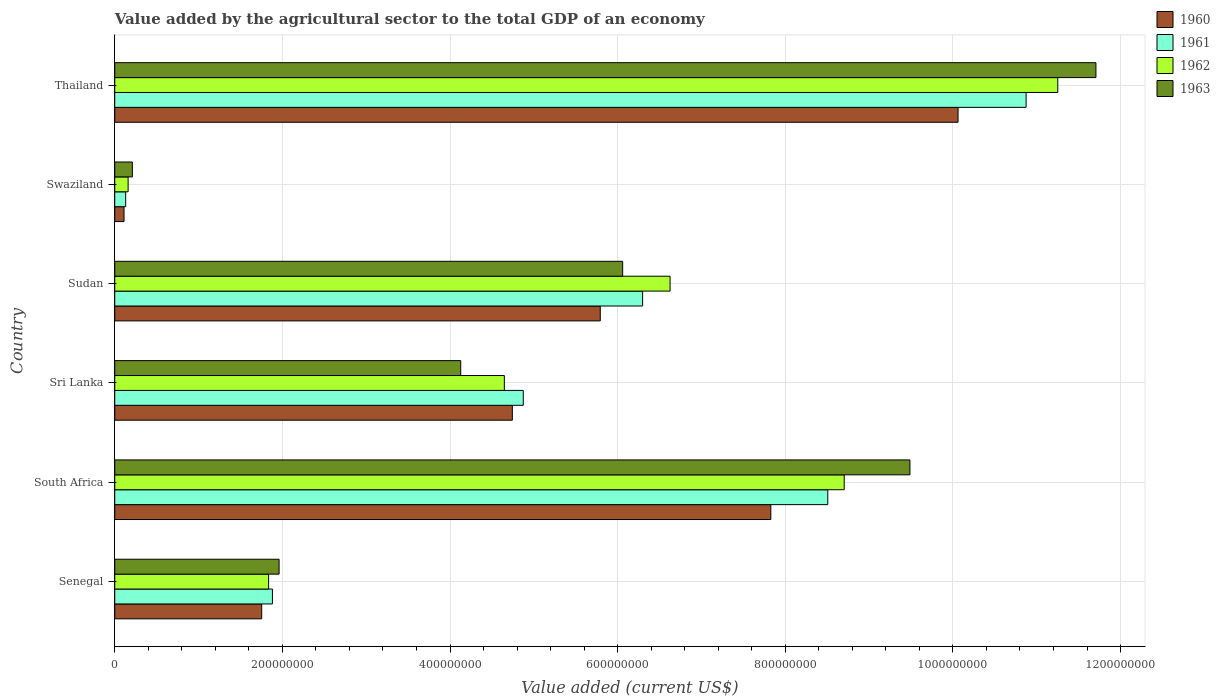How many different coloured bars are there?
Offer a very short reply. 4. Are the number of bars on each tick of the Y-axis equal?
Your answer should be very brief. Yes. How many bars are there on the 4th tick from the top?
Provide a short and direct response. 4. How many bars are there on the 1st tick from the bottom?
Offer a very short reply. 4. What is the label of the 4th group of bars from the top?
Make the answer very short. Sri Lanka. In how many cases, is the number of bars for a given country not equal to the number of legend labels?
Your response must be concise. 0. What is the value added by the agricultural sector to the total GDP in 1963 in Sudan?
Give a very brief answer. 6.06e+08. Across all countries, what is the maximum value added by the agricultural sector to the total GDP in 1961?
Your answer should be very brief. 1.09e+09. Across all countries, what is the minimum value added by the agricultural sector to the total GDP in 1961?
Offer a terse response. 1.30e+07. In which country was the value added by the agricultural sector to the total GDP in 1963 maximum?
Provide a short and direct response. Thailand. In which country was the value added by the agricultural sector to the total GDP in 1962 minimum?
Provide a short and direct response. Swaziland. What is the total value added by the agricultural sector to the total GDP in 1962 in the graph?
Keep it short and to the point. 3.32e+09. What is the difference between the value added by the agricultural sector to the total GDP in 1963 in South Africa and that in Thailand?
Your response must be concise. -2.22e+08. What is the difference between the value added by the agricultural sector to the total GDP in 1962 in Sri Lanka and the value added by the agricultural sector to the total GDP in 1960 in Senegal?
Make the answer very short. 2.89e+08. What is the average value added by the agricultural sector to the total GDP in 1963 per country?
Make the answer very short. 5.59e+08. What is the difference between the value added by the agricultural sector to the total GDP in 1961 and value added by the agricultural sector to the total GDP in 1962 in Thailand?
Make the answer very short. -3.78e+07. In how many countries, is the value added by the agricultural sector to the total GDP in 1962 greater than 960000000 US$?
Offer a terse response. 1. What is the ratio of the value added by the agricultural sector to the total GDP in 1960 in Senegal to that in Thailand?
Provide a succinct answer. 0.17. What is the difference between the highest and the second highest value added by the agricultural sector to the total GDP in 1962?
Offer a very short reply. 2.55e+08. What is the difference between the highest and the lowest value added by the agricultural sector to the total GDP in 1960?
Make the answer very short. 9.95e+08. In how many countries, is the value added by the agricultural sector to the total GDP in 1960 greater than the average value added by the agricultural sector to the total GDP in 1960 taken over all countries?
Offer a very short reply. 3. Is the sum of the value added by the agricultural sector to the total GDP in 1963 in South Africa and Sudan greater than the maximum value added by the agricultural sector to the total GDP in 1961 across all countries?
Keep it short and to the point. Yes. How many bars are there?
Offer a terse response. 24. What is the difference between two consecutive major ticks on the X-axis?
Offer a terse response. 2.00e+08. Are the values on the major ticks of X-axis written in scientific E-notation?
Keep it short and to the point. No. Does the graph contain any zero values?
Make the answer very short. No. Where does the legend appear in the graph?
Give a very brief answer. Top right. How are the legend labels stacked?
Offer a terse response. Vertical. What is the title of the graph?
Provide a short and direct response. Value added by the agricultural sector to the total GDP of an economy. What is the label or title of the X-axis?
Make the answer very short. Value added (current US$). What is the Value added (current US$) in 1960 in Senegal?
Your response must be concise. 1.75e+08. What is the Value added (current US$) in 1961 in Senegal?
Provide a succinct answer. 1.88e+08. What is the Value added (current US$) of 1962 in Senegal?
Ensure brevity in your answer.  1.84e+08. What is the Value added (current US$) of 1963 in Senegal?
Offer a very short reply. 1.96e+08. What is the Value added (current US$) of 1960 in South Africa?
Make the answer very short. 7.83e+08. What is the Value added (current US$) of 1961 in South Africa?
Make the answer very short. 8.51e+08. What is the Value added (current US$) in 1962 in South Africa?
Offer a very short reply. 8.70e+08. What is the Value added (current US$) in 1963 in South Africa?
Keep it short and to the point. 9.49e+08. What is the Value added (current US$) of 1960 in Sri Lanka?
Offer a very short reply. 4.74e+08. What is the Value added (current US$) in 1961 in Sri Lanka?
Make the answer very short. 4.87e+08. What is the Value added (current US$) in 1962 in Sri Lanka?
Make the answer very short. 4.65e+08. What is the Value added (current US$) in 1963 in Sri Lanka?
Provide a succinct answer. 4.13e+08. What is the Value added (current US$) of 1960 in Sudan?
Your answer should be very brief. 5.79e+08. What is the Value added (current US$) of 1961 in Sudan?
Make the answer very short. 6.30e+08. What is the Value added (current US$) of 1962 in Sudan?
Make the answer very short. 6.63e+08. What is the Value added (current US$) in 1963 in Sudan?
Your response must be concise. 6.06e+08. What is the Value added (current US$) of 1960 in Swaziland?
Keep it short and to the point. 1.11e+07. What is the Value added (current US$) in 1961 in Swaziland?
Offer a very short reply. 1.30e+07. What is the Value added (current US$) of 1962 in Swaziland?
Keep it short and to the point. 1.60e+07. What is the Value added (current US$) in 1963 in Swaziland?
Make the answer very short. 2.10e+07. What is the Value added (current US$) of 1960 in Thailand?
Your response must be concise. 1.01e+09. What is the Value added (current US$) in 1961 in Thailand?
Offer a terse response. 1.09e+09. What is the Value added (current US$) of 1962 in Thailand?
Your answer should be very brief. 1.13e+09. What is the Value added (current US$) of 1963 in Thailand?
Your response must be concise. 1.17e+09. Across all countries, what is the maximum Value added (current US$) in 1960?
Ensure brevity in your answer.  1.01e+09. Across all countries, what is the maximum Value added (current US$) of 1961?
Ensure brevity in your answer.  1.09e+09. Across all countries, what is the maximum Value added (current US$) of 1962?
Ensure brevity in your answer.  1.13e+09. Across all countries, what is the maximum Value added (current US$) of 1963?
Keep it short and to the point. 1.17e+09. Across all countries, what is the minimum Value added (current US$) of 1960?
Give a very brief answer. 1.11e+07. Across all countries, what is the minimum Value added (current US$) of 1961?
Your response must be concise. 1.30e+07. Across all countries, what is the minimum Value added (current US$) of 1962?
Your answer should be very brief. 1.60e+07. Across all countries, what is the minimum Value added (current US$) of 1963?
Provide a succinct answer. 2.10e+07. What is the total Value added (current US$) of 1960 in the graph?
Your answer should be very brief. 3.03e+09. What is the total Value added (current US$) of 1961 in the graph?
Offer a very short reply. 3.26e+09. What is the total Value added (current US$) of 1962 in the graph?
Make the answer very short. 3.32e+09. What is the total Value added (current US$) of 1963 in the graph?
Your answer should be very brief. 3.36e+09. What is the difference between the Value added (current US$) of 1960 in Senegal and that in South Africa?
Make the answer very short. -6.07e+08. What is the difference between the Value added (current US$) of 1961 in Senegal and that in South Africa?
Your answer should be compact. -6.63e+08. What is the difference between the Value added (current US$) of 1962 in Senegal and that in South Africa?
Ensure brevity in your answer.  -6.87e+08. What is the difference between the Value added (current US$) in 1963 in Senegal and that in South Africa?
Provide a succinct answer. -7.53e+08. What is the difference between the Value added (current US$) in 1960 in Senegal and that in Sri Lanka?
Give a very brief answer. -2.99e+08. What is the difference between the Value added (current US$) in 1961 in Senegal and that in Sri Lanka?
Provide a succinct answer. -2.99e+08. What is the difference between the Value added (current US$) in 1962 in Senegal and that in Sri Lanka?
Your answer should be very brief. -2.81e+08. What is the difference between the Value added (current US$) in 1963 in Senegal and that in Sri Lanka?
Ensure brevity in your answer.  -2.17e+08. What is the difference between the Value added (current US$) in 1960 in Senegal and that in Sudan?
Keep it short and to the point. -4.04e+08. What is the difference between the Value added (current US$) in 1961 in Senegal and that in Sudan?
Your answer should be very brief. -4.42e+08. What is the difference between the Value added (current US$) in 1962 in Senegal and that in Sudan?
Give a very brief answer. -4.79e+08. What is the difference between the Value added (current US$) of 1963 in Senegal and that in Sudan?
Provide a succinct answer. -4.10e+08. What is the difference between the Value added (current US$) of 1960 in Senegal and that in Swaziland?
Offer a terse response. 1.64e+08. What is the difference between the Value added (current US$) in 1961 in Senegal and that in Swaziland?
Your answer should be very brief. 1.75e+08. What is the difference between the Value added (current US$) in 1962 in Senegal and that in Swaziland?
Offer a terse response. 1.68e+08. What is the difference between the Value added (current US$) in 1963 in Senegal and that in Swaziland?
Give a very brief answer. 1.75e+08. What is the difference between the Value added (current US$) in 1960 in Senegal and that in Thailand?
Offer a terse response. -8.31e+08. What is the difference between the Value added (current US$) of 1961 in Senegal and that in Thailand?
Offer a very short reply. -8.99e+08. What is the difference between the Value added (current US$) in 1962 in Senegal and that in Thailand?
Offer a very short reply. -9.42e+08. What is the difference between the Value added (current US$) of 1963 in Senegal and that in Thailand?
Offer a very short reply. -9.75e+08. What is the difference between the Value added (current US$) in 1960 in South Africa and that in Sri Lanka?
Make the answer very short. 3.08e+08. What is the difference between the Value added (current US$) in 1961 in South Africa and that in Sri Lanka?
Keep it short and to the point. 3.63e+08. What is the difference between the Value added (current US$) of 1962 in South Africa and that in Sri Lanka?
Your answer should be very brief. 4.06e+08. What is the difference between the Value added (current US$) of 1963 in South Africa and that in Sri Lanka?
Offer a terse response. 5.36e+08. What is the difference between the Value added (current US$) in 1960 in South Africa and that in Sudan?
Offer a very short reply. 2.04e+08. What is the difference between the Value added (current US$) in 1961 in South Africa and that in Sudan?
Your answer should be very brief. 2.21e+08. What is the difference between the Value added (current US$) of 1962 in South Africa and that in Sudan?
Offer a very short reply. 2.08e+08. What is the difference between the Value added (current US$) of 1963 in South Africa and that in Sudan?
Your response must be concise. 3.43e+08. What is the difference between the Value added (current US$) of 1960 in South Africa and that in Swaziland?
Offer a very short reply. 7.72e+08. What is the difference between the Value added (current US$) in 1961 in South Africa and that in Swaziland?
Offer a very short reply. 8.38e+08. What is the difference between the Value added (current US$) of 1962 in South Africa and that in Swaziland?
Give a very brief answer. 8.54e+08. What is the difference between the Value added (current US$) of 1963 in South Africa and that in Swaziland?
Make the answer very short. 9.28e+08. What is the difference between the Value added (current US$) of 1960 in South Africa and that in Thailand?
Offer a terse response. -2.23e+08. What is the difference between the Value added (current US$) in 1961 in South Africa and that in Thailand?
Keep it short and to the point. -2.37e+08. What is the difference between the Value added (current US$) of 1962 in South Africa and that in Thailand?
Your response must be concise. -2.55e+08. What is the difference between the Value added (current US$) in 1963 in South Africa and that in Thailand?
Your answer should be very brief. -2.22e+08. What is the difference between the Value added (current US$) of 1960 in Sri Lanka and that in Sudan?
Make the answer very short. -1.05e+08. What is the difference between the Value added (current US$) of 1961 in Sri Lanka and that in Sudan?
Your answer should be compact. -1.42e+08. What is the difference between the Value added (current US$) of 1962 in Sri Lanka and that in Sudan?
Provide a succinct answer. -1.98e+08. What is the difference between the Value added (current US$) in 1963 in Sri Lanka and that in Sudan?
Make the answer very short. -1.93e+08. What is the difference between the Value added (current US$) in 1960 in Sri Lanka and that in Swaziland?
Provide a succinct answer. 4.63e+08. What is the difference between the Value added (current US$) in 1961 in Sri Lanka and that in Swaziland?
Your answer should be very brief. 4.74e+08. What is the difference between the Value added (current US$) in 1962 in Sri Lanka and that in Swaziland?
Provide a short and direct response. 4.49e+08. What is the difference between the Value added (current US$) of 1963 in Sri Lanka and that in Swaziland?
Your answer should be compact. 3.92e+08. What is the difference between the Value added (current US$) of 1960 in Sri Lanka and that in Thailand?
Your answer should be very brief. -5.32e+08. What is the difference between the Value added (current US$) of 1961 in Sri Lanka and that in Thailand?
Your answer should be compact. -6.00e+08. What is the difference between the Value added (current US$) of 1962 in Sri Lanka and that in Thailand?
Keep it short and to the point. -6.60e+08. What is the difference between the Value added (current US$) in 1963 in Sri Lanka and that in Thailand?
Provide a short and direct response. -7.58e+08. What is the difference between the Value added (current US$) of 1960 in Sudan and that in Swaziland?
Keep it short and to the point. 5.68e+08. What is the difference between the Value added (current US$) of 1961 in Sudan and that in Swaziland?
Give a very brief answer. 6.17e+08. What is the difference between the Value added (current US$) in 1962 in Sudan and that in Swaziland?
Provide a short and direct response. 6.47e+08. What is the difference between the Value added (current US$) of 1963 in Sudan and that in Swaziland?
Offer a very short reply. 5.85e+08. What is the difference between the Value added (current US$) in 1960 in Sudan and that in Thailand?
Ensure brevity in your answer.  -4.27e+08. What is the difference between the Value added (current US$) of 1961 in Sudan and that in Thailand?
Your response must be concise. -4.58e+08. What is the difference between the Value added (current US$) of 1962 in Sudan and that in Thailand?
Make the answer very short. -4.63e+08. What is the difference between the Value added (current US$) in 1963 in Sudan and that in Thailand?
Give a very brief answer. -5.65e+08. What is the difference between the Value added (current US$) in 1960 in Swaziland and that in Thailand?
Offer a terse response. -9.95e+08. What is the difference between the Value added (current US$) of 1961 in Swaziland and that in Thailand?
Your response must be concise. -1.07e+09. What is the difference between the Value added (current US$) in 1962 in Swaziland and that in Thailand?
Provide a short and direct response. -1.11e+09. What is the difference between the Value added (current US$) of 1963 in Swaziland and that in Thailand?
Provide a short and direct response. -1.15e+09. What is the difference between the Value added (current US$) of 1960 in Senegal and the Value added (current US$) of 1961 in South Africa?
Offer a terse response. -6.75e+08. What is the difference between the Value added (current US$) of 1960 in Senegal and the Value added (current US$) of 1962 in South Africa?
Your response must be concise. -6.95e+08. What is the difference between the Value added (current US$) in 1960 in Senegal and the Value added (current US$) in 1963 in South Africa?
Your response must be concise. -7.73e+08. What is the difference between the Value added (current US$) of 1961 in Senegal and the Value added (current US$) of 1962 in South Africa?
Your answer should be compact. -6.82e+08. What is the difference between the Value added (current US$) of 1961 in Senegal and the Value added (current US$) of 1963 in South Africa?
Your answer should be very brief. -7.61e+08. What is the difference between the Value added (current US$) in 1962 in Senegal and the Value added (current US$) in 1963 in South Africa?
Keep it short and to the point. -7.65e+08. What is the difference between the Value added (current US$) in 1960 in Senegal and the Value added (current US$) in 1961 in Sri Lanka?
Provide a short and direct response. -3.12e+08. What is the difference between the Value added (current US$) of 1960 in Senegal and the Value added (current US$) of 1962 in Sri Lanka?
Give a very brief answer. -2.89e+08. What is the difference between the Value added (current US$) of 1960 in Senegal and the Value added (current US$) of 1963 in Sri Lanka?
Give a very brief answer. -2.37e+08. What is the difference between the Value added (current US$) of 1961 in Senegal and the Value added (current US$) of 1962 in Sri Lanka?
Provide a short and direct response. -2.77e+08. What is the difference between the Value added (current US$) in 1961 in Senegal and the Value added (current US$) in 1963 in Sri Lanka?
Keep it short and to the point. -2.25e+08. What is the difference between the Value added (current US$) of 1962 in Senegal and the Value added (current US$) of 1963 in Sri Lanka?
Make the answer very short. -2.29e+08. What is the difference between the Value added (current US$) in 1960 in Senegal and the Value added (current US$) in 1961 in Sudan?
Your answer should be very brief. -4.54e+08. What is the difference between the Value added (current US$) of 1960 in Senegal and the Value added (current US$) of 1962 in Sudan?
Ensure brevity in your answer.  -4.87e+08. What is the difference between the Value added (current US$) of 1960 in Senegal and the Value added (current US$) of 1963 in Sudan?
Ensure brevity in your answer.  -4.31e+08. What is the difference between the Value added (current US$) in 1961 in Senegal and the Value added (current US$) in 1962 in Sudan?
Your answer should be very brief. -4.74e+08. What is the difference between the Value added (current US$) in 1961 in Senegal and the Value added (current US$) in 1963 in Sudan?
Keep it short and to the point. -4.18e+08. What is the difference between the Value added (current US$) in 1962 in Senegal and the Value added (current US$) in 1963 in Sudan?
Your answer should be compact. -4.22e+08. What is the difference between the Value added (current US$) in 1960 in Senegal and the Value added (current US$) in 1961 in Swaziland?
Offer a terse response. 1.62e+08. What is the difference between the Value added (current US$) of 1960 in Senegal and the Value added (current US$) of 1962 in Swaziland?
Your answer should be compact. 1.59e+08. What is the difference between the Value added (current US$) of 1960 in Senegal and the Value added (current US$) of 1963 in Swaziland?
Ensure brevity in your answer.  1.54e+08. What is the difference between the Value added (current US$) of 1961 in Senegal and the Value added (current US$) of 1962 in Swaziland?
Your response must be concise. 1.72e+08. What is the difference between the Value added (current US$) of 1961 in Senegal and the Value added (current US$) of 1963 in Swaziland?
Offer a terse response. 1.67e+08. What is the difference between the Value added (current US$) of 1962 in Senegal and the Value added (current US$) of 1963 in Swaziland?
Make the answer very short. 1.63e+08. What is the difference between the Value added (current US$) of 1960 in Senegal and the Value added (current US$) of 1961 in Thailand?
Provide a succinct answer. -9.12e+08. What is the difference between the Value added (current US$) in 1960 in Senegal and the Value added (current US$) in 1962 in Thailand?
Provide a succinct answer. -9.50e+08. What is the difference between the Value added (current US$) of 1960 in Senegal and the Value added (current US$) of 1963 in Thailand?
Your answer should be compact. -9.95e+08. What is the difference between the Value added (current US$) of 1961 in Senegal and the Value added (current US$) of 1962 in Thailand?
Your response must be concise. -9.37e+08. What is the difference between the Value added (current US$) in 1961 in Senegal and the Value added (current US$) in 1963 in Thailand?
Your response must be concise. -9.83e+08. What is the difference between the Value added (current US$) of 1962 in Senegal and the Value added (current US$) of 1963 in Thailand?
Provide a short and direct response. -9.87e+08. What is the difference between the Value added (current US$) in 1960 in South Africa and the Value added (current US$) in 1961 in Sri Lanka?
Your answer should be very brief. 2.95e+08. What is the difference between the Value added (current US$) of 1960 in South Africa and the Value added (current US$) of 1962 in Sri Lanka?
Ensure brevity in your answer.  3.18e+08. What is the difference between the Value added (current US$) of 1960 in South Africa and the Value added (current US$) of 1963 in Sri Lanka?
Give a very brief answer. 3.70e+08. What is the difference between the Value added (current US$) of 1961 in South Africa and the Value added (current US$) of 1962 in Sri Lanka?
Provide a short and direct response. 3.86e+08. What is the difference between the Value added (current US$) of 1961 in South Africa and the Value added (current US$) of 1963 in Sri Lanka?
Your answer should be compact. 4.38e+08. What is the difference between the Value added (current US$) of 1962 in South Africa and the Value added (current US$) of 1963 in Sri Lanka?
Your response must be concise. 4.58e+08. What is the difference between the Value added (current US$) in 1960 in South Africa and the Value added (current US$) in 1961 in Sudan?
Offer a terse response. 1.53e+08. What is the difference between the Value added (current US$) in 1960 in South Africa and the Value added (current US$) in 1962 in Sudan?
Provide a succinct answer. 1.20e+08. What is the difference between the Value added (current US$) of 1960 in South Africa and the Value added (current US$) of 1963 in Sudan?
Provide a succinct answer. 1.77e+08. What is the difference between the Value added (current US$) of 1961 in South Africa and the Value added (current US$) of 1962 in Sudan?
Give a very brief answer. 1.88e+08. What is the difference between the Value added (current US$) in 1961 in South Africa and the Value added (current US$) in 1963 in Sudan?
Ensure brevity in your answer.  2.45e+08. What is the difference between the Value added (current US$) of 1962 in South Africa and the Value added (current US$) of 1963 in Sudan?
Your answer should be very brief. 2.64e+08. What is the difference between the Value added (current US$) of 1960 in South Africa and the Value added (current US$) of 1961 in Swaziland?
Your answer should be compact. 7.70e+08. What is the difference between the Value added (current US$) in 1960 in South Africa and the Value added (current US$) in 1962 in Swaziland?
Offer a terse response. 7.67e+08. What is the difference between the Value added (current US$) in 1960 in South Africa and the Value added (current US$) in 1963 in Swaziland?
Provide a short and direct response. 7.62e+08. What is the difference between the Value added (current US$) in 1961 in South Africa and the Value added (current US$) in 1962 in Swaziland?
Give a very brief answer. 8.35e+08. What is the difference between the Value added (current US$) in 1961 in South Africa and the Value added (current US$) in 1963 in Swaziland?
Your answer should be compact. 8.30e+08. What is the difference between the Value added (current US$) of 1962 in South Africa and the Value added (current US$) of 1963 in Swaziland?
Your response must be concise. 8.49e+08. What is the difference between the Value added (current US$) in 1960 in South Africa and the Value added (current US$) in 1961 in Thailand?
Provide a succinct answer. -3.05e+08. What is the difference between the Value added (current US$) of 1960 in South Africa and the Value added (current US$) of 1962 in Thailand?
Offer a very short reply. -3.42e+08. What is the difference between the Value added (current US$) in 1960 in South Africa and the Value added (current US$) in 1963 in Thailand?
Offer a very short reply. -3.88e+08. What is the difference between the Value added (current US$) of 1961 in South Africa and the Value added (current US$) of 1962 in Thailand?
Ensure brevity in your answer.  -2.74e+08. What is the difference between the Value added (current US$) of 1961 in South Africa and the Value added (current US$) of 1963 in Thailand?
Provide a short and direct response. -3.20e+08. What is the difference between the Value added (current US$) of 1962 in South Africa and the Value added (current US$) of 1963 in Thailand?
Keep it short and to the point. -3.00e+08. What is the difference between the Value added (current US$) in 1960 in Sri Lanka and the Value added (current US$) in 1961 in Sudan?
Keep it short and to the point. -1.55e+08. What is the difference between the Value added (current US$) of 1960 in Sri Lanka and the Value added (current US$) of 1962 in Sudan?
Make the answer very short. -1.88e+08. What is the difference between the Value added (current US$) of 1960 in Sri Lanka and the Value added (current US$) of 1963 in Sudan?
Give a very brief answer. -1.32e+08. What is the difference between the Value added (current US$) in 1961 in Sri Lanka and the Value added (current US$) in 1962 in Sudan?
Your response must be concise. -1.75e+08. What is the difference between the Value added (current US$) of 1961 in Sri Lanka and the Value added (current US$) of 1963 in Sudan?
Make the answer very short. -1.19e+08. What is the difference between the Value added (current US$) in 1962 in Sri Lanka and the Value added (current US$) in 1963 in Sudan?
Keep it short and to the point. -1.41e+08. What is the difference between the Value added (current US$) in 1960 in Sri Lanka and the Value added (current US$) in 1961 in Swaziland?
Your response must be concise. 4.61e+08. What is the difference between the Value added (current US$) in 1960 in Sri Lanka and the Value added (current US$) in 1962 in Swaziland?
Provide a short and direct response. 4.58e+08. What is the difference between the Value added (current US$) in 1960 in Sri Lanka and the Value added (current US$) in 1963 in Swaziland?
Offer a terse response. 4.53e+08. What is the difference between the Value added (current US$) of 1961 in Sri Lanka and the Value added (current US$) of 1962 in Swaziland?
Your answer should be compact. 4.71e+08. What is the difference between the Value added (current US$) of 1961 in Sri Lanka and the Value added (current US$) of 1963 in Swaziland?
Your response must be concise. 4.66e+08. What is the difference between the Value added (current US$) of 1962 in Sri Lanka and the Value added (current US$) of 1963 in Swaziland?
Your answer should be very brief. 4.44e+08. What is the difference between the Value added (current US$) of 1960 in Sri Lanka and the Value added (current US$) of 1961 in Thailand?
Provide a short and direct response. -6.13e+08. What is the difference between the Value added (current US$) in 1960 in Sri Lanka and the Value added (current US$) in 1962 in Thailand?
Offer a terse response. -6.51e+08. What is the difference between the Value added (current US$) in 1960 in Sri Lanka and the Value added (current US$) in 1963 in Thailand?
Your response must be concise. -6.96e+08. What is the difference between the Value added (current US$) of 1961 in Sri Lanka and the Value added (current US$) of 1962 in Thailand?
Make the answer very short. -6.38e+08. What is the difference between the Value added (current US$) of 1961 in Sri Lanka and the Value added (current US$) of 1963 in Thailand?
Provide a succinct answer. -6.83e+08. What is the difference between the Value added (current US$) of 1962 in Sri Lanka and the Value added (current US$) of 1963 in Thailand?
Your answer should be very brief. -7.06e+08. What is the difference between the Value added (current US$) in 1960 in Sudan and the Value added (current US$) in 1961 in Swaziland?
Make the answer very short. 5.66e+08. What is the difference between the Value added (current US$) of 1960 in Sudan and the Value added (current US$) of 1962 in Swaziland?
Your answer should be compact. 5.63e+08. What is the difference between the Value added (current US$) of 1960 in Sudan and the Value added (current US$) of 1963 in Swaziland?
Offer a terse response. 5.58e+08. What is the difference between the Value added (current US$) of 1961 in Sudan and the Value added (current US$) of 1962 in Swaziland?
Give a very brief answer. 6.14e+08. What is the difference between the Value added (current US$) in 1961 in Sudan and the Value added (current US$) in 1963 in Swaziland?
Offer a very short reply. 6.09e+08. What is the difference between the Value added (current US$) in 1962 in Sudan and the Value added (current US$) in 1963 in Swaziland?
Ensure brevity in your answer.  6.42e+08. What is the difference between the Value added (current US$) of 1960 in Sudan and the Value added (current US$) of 1961 in Thailand?
Ensure brevity in your answer.  -5.08e+08. What is the difference between the Value added (current US$) of 1960 in Sudan and the Value added (current US$) of 1962 in Thailand?
Your answer should be compact. -5.46e+08. What is the difference between the Value added (current US$) of 1960 in Sudan and the Value added (current US$) of 1963 in Thailand?
Give a very brief answer. -5.91e+08. What is the difference between the Value added (current US$) in 1961 in Sudan and the Value added (current US$) in 1962 in Thailand?
Keep it short and to the point. -4.95e+08. What is the difference between the Value added (current US$) in 1961 in Sudan and the Value added (current US$) in 1963 in Thailand?
Ensure brevity in your answer.  -5.41e+08. What is the difference between the Value added (current US$) in 1962 in Sudan and the Value added (current US$) in 1963 in Thailand?
Your response must be concise. -5.08e+08. What is the difference between the Value added (current US$) in 1960 in Swaziland and the Value added (current US$) in 1961 in Thailand?
Offer a very short reply. -1.08e+09. What is the difference between the Value added (current US$) of 1960 in Swaziland and the Value added (current US$) of 1962 in Thailand?
Your answer should be compact. -1.11e+09. What is the difference between the Value added (current US$) of 1960 in Swaziland and the Value added (current US$) of 1963 in Thailand?
Give a very brief answer. -1.16e+09. What is the difference between the Value added (current US$) in 1961 in Swaziland and the Value added (current US$) in 1962 in Thailand?
Keep it short and to the point. -1.11e+09. What is the difference between the Value added (current US$) in 1961 in Swaziland and the Value added (current US$) in 1963 in Thailand?
Keep it short and to the point. -1.16e+09. What is the difference between the Value added (current US$) in 1962 in Swaziland and the Value added (current US$) in 1963 in Thailand?
Keep it short and to the point. -1.15e+09. What is the average Value added (current US$) of 1960 per country?
Your answer should be very brief. 5.05e+08. What is the average Value added (current US$) in 1961 per country?
Give a very brief answer. 5.43e+08. What is the average Value added (current US$) in 1962 per country?
Your answer should be compact. 5.54e+08. What is the average Value added (current US$) of 1963 per country?
Offer a terse response. 5.59e+08. What is the difference between the Value added (current US$) of 1960 and Value added (current US$) of 1961 in Senegal?
Provide a succinct answer. -1.28e+07. What is the difference between the Value added (current US$) of 1960 and Value added (current US$) of 1962 in Senegal?
Keep it short and to the point. -8.24e+06. What is the difference between the Value added (current US$) of 1960 and Value added (current US$) of 1963 in Senegal?
Provide a short and direct response. -2.07e+07. What is the difference between the Value added (current US$) of 1961 and Value added (current US$) of 1962 in Senegal?
Ensure brevity in your answer.  4.54e+06. What is the difference between the Value added (current US$) in 1961 and Value added (current US$) in 1963 in Senegal?
Ensure brevity in your answer.  -7.96e+06. What is the difference between the Value added (current US$) in 1962 and Value added (current US$) in 1963 in Senegal?
Provide a short and direct response. -1.25e+07. What is the difference between the Value added (current US$) in 1960 and Value added (current US$) in 1961 in South Africa?
Ensure brevity in your answer.  -6.80e+07. What is the difference between the Value added (current US$) of 1960 and Value added (current US$) of 1962 in South Africa?
Offer a very short reply. -8.76e+07. What is the difference between the Value added (current US$) of 1960 and Value added (current US$) of 1963 in South Africa?
Your answer should be very brief. -1.66e+08. What is the difference between the Value added (current US$) of 1961 and Value added (current US$) of 1962 in South Africa?
Keep it short and to the point. -1.96e+07. What is the difference between the Value added (current US$) in 1961 and Value added (current US$) in 1963 in South Africa?
Your response must be concise. -9.80e+07. What is the difference between the Value added (current US$) of 1962 and Value added (current US$) of 1963 in South Africa?
Provide a short and direct response. -7.84e+07. What is the difference between the Value added (current US$) in 1960 and Value added (current US$) in 1961 in Sri Lanka?
Ensure brevity in your answer.  -1.30e+07. What is the difference between the Value added (current US$) in 1960 and Value added (current US$) in 1962 in Sri Lanka?
Make the answer very short. 9.55e+06. What is the difference between the Value added (current US$) of 1960 and Value added (current US$) of 1963 in Sri Lanka?
Your answer should be very brief. 6.16e+07. What is the difference between the Value added (current US$) of 1961 and Value added (current US$) of 1962 in Sri Lanka?
Provide a succinct answer. 2.26e+07. What is the difference between the Value added (current US$) in 1961 and Value added (current US$) in 1963 in Sri Lanka?
Give a very brief answer. 7.46e+07. What is the difference between the Value added (current US$) of 1962 and Value added (current US$) of 1963 in Sri Lanka?
Your answer should be very brief. 5.20e+07. What is the difference between the Value added (current US$) in 1960 and Value added (current US$) in 1961 in Sudan?
Offer a very short reply. -5.05e+07. What is the difference between the Value added (current US$) in 1960 and Value added (current US$) in 1962 in Sudan?
Your response must be concise. -8.33e+07. What is the difference between the Value added (current US$) of 1960 and Value added (current US$) of 1963 in Sudan?
Provide a succinct answer. -2.67e+07. What is the difference between the Value added (current US$) in 1961 and Value added (current US$) in 1962 in Sudan?
Keep it short and to the point. -3.27e+07. What is the difference between the Value added (current US$) of 1961 and Value added (current US$) of 1963 in Sudan?
Offer a very short reply. 2.38e+07. What is the difference between the Value added (current US$) in 1962 and Value added (current US$) in 1963 in Sudan?
Provide a succinct answer. 5.66e+07. What is the difference between the Value added (current US$) of 1960 and Value added (current US$) of 1961 in Swaziland?
Ensure brevity in your answer.  -1.96e+06. What is the difference between the Value added (current US$) in 1960 and Value added (current US$) in 1962 in Swaziland?
Your answer should be compact. -4.90e+06. What is the difference between the Value added (current US$) in 1960 and Value added (current US$) in 1963 in Swaziland?
Make the answer very short. -9.94e+06. What is the difference between the Value added (current US$) in 1961 and Value added (current US$) in 1962 in Swaziland?
Ensure brevity in your answer.  -2.94e+06. What is the difference between the Value added (current US$) in 1961 and Value added (current US$) in 1963 in Swaziland?
Make the answer very short. -7.98e+06. What is the difference between the Value added (current US$) of 1962 and Value added (current US$) of 1963 in Swaziland?
Offer a terse response. -5.04e+06. What is the difference between the Value added (current US$) of 1960 and Value added (current US$) of 1961 in Thailand?
Offer a terse response. -8.12e+07. What is the difference between the Value added (current US$) of 1960 and Value added (current US$) of 1962 in Thailand?
Your answer should be very brief. -1.19e+08. What is the difference between the Value added (current US$) in 1960 and Value added (current US$) in 1963 in Thailand?
Make the answer very short. -1.65e+08. What is the difference between the Value added (current US$) of 1961 and Value added (current US$) of 1962 in Thailand?
Provide a succinct answer. -3.78e+07. What is the difference between the Value added (current US$) of 1961 and Value added (current US$) of 1963 in Thailand?
Provide a succinct answer. -8.33e+07. What is the difference between the Value added (current US$) of 1962 and Value added (current US$) of 1963 in Thailand?
Your answer should be very brief. -4.55e+07. What is the ratio of the Value added (current US$) in 1960 in Senegal to that in South Africa?
Make the answer very short. 0.22. What is the ratio of the Value added (current US$) in 1961 in Senegal to that in South Africa?
Give a very brief answer. 0.22. What is the ratio of the Value added (current US$) in 1962 in Senegal to that in South Africa?
Ensure brevity in your answer.  0.21. What is the ratio of the Value added (current US$) in 1963 in Senegal to that in South Africa?
Keep it short and to the point. 0.21. What is the ratio of the Value added (current US$) in 1960 in Senegal to that in Sri Lanka?
Make the answer very short. 0.37. What is the ratio of the Value added (current US$) of 1961 in Senegal to that in Sri Lanka?
Your answer should be very brief. 0.39. What is the ratio of the Value added (current US$) in 1962 in Senegal to that in Sri Lanka?
Offer a terse response. 0.39. What is the ratio of the Value added (current US$) in 1963 in Senegal to that in Sri Lanka?
Your answer should be very brief. 0.47. What is the ratio of the Value added (current US$) in 1960 in Senegal to that in Sudan?
Give a very brief answer. 0.3. What is the ratio of the Value added (current US$) of 1961 in Senegal to that in Sudan?
Offer a very short reply. 0.3. What is the ratio of the Value added (current US$) of 1962 in Senegal to that in Sudan?
Offer a terse response. 0.28. What is the ratio of the Value added (current US$) of 1963 in Senegal to that in Sudan?
Keep it short and to the point. 0.32. What is the ratio of the Value added (current US$) in 1960 in Senegal to that in Swaziland?
Keep it short and to the point. 15.85. What is the ratio of the Value added (current US$) in 1961 in Senegal to that in Swaziland?
Your response must be concise. 14.45. What is the ratio of the Value added (current US$) of 1962 in Senegal to that in Swaziland?
Provide a succinct answer. 11.5. What is the ratio of the Value added (current US$) in 1963 in Senegal to that in Swaziland?
Make the answer very short. 9.34. What is the ratio of the Value added (current US$) of 1960 in Senegal to that in Thailand?
Offer a terse response. 0.17. What is the ratio of the Value added (current US$) of 1961 in Senegal to that in Thailand?
Your answer should be compact. 0.17. What is the ratio of the Value added (current US$) of 1962 in Senegal to that in Thailand?
Provide a succinct answer. 0.16. What is the ratio of the Value added (current US$) of 1963 in Senegal to that in Thailand?
Your answer should be very brief. 0.17. What is the ratio of the Value added (current US$) of 1960 in South Africa to that in Sri Lanka?
Offer a very short reply. 1.65. What is the ratio of the Value added (current US$) in 1961 in South Africa to that in Sri Lanka?
Offer a very short reply. 1.75. What is the ratio of the Value added (current US$) of 1962 in South Africa to that in Sri Lanka?
Offer a terse response. 1.87. What is the ratio of the Value added (current US$) in 1963 in South Africa to that in Sri Lanka?
Provide a short and direct response. 2.3. What is the ratio of the Value added (current US$) in 1960 in South Africa to that in Sudan?
Keep it short and to the point. 1.35. What is the ratio of the Value added (current US$) of 1961 in South Africa to that in Sudan?
Ensure brevity in your answer.  1.35. What is the ratio of the Value added (current US$) in 1962 in South Africa to that in Sudan?
Give a very brief answer. 1.31. What is the ratio of the Value added (current US$) in 1963 in South Africa to that in Sudan?
Provide a succinct answer. 1.57. What is the ratio of the Value added (current US$) in 1960 in South Africa to that in Swaziland?
Provide a short and direct response. 70.77. What is the ratio of the Value added (current US$) of 1961 in South Africa to that in Swaziland?
Provide a succinct answer. 65.34. What is the ratio of the Value added (current US$) of 1962 in South Africa to that in Swaziland?
Offer a very short reply. 54.53. What is the ratio of the Value added (current US$) of 1963 in South Africa to that in Swaziland?
Offer a very short reply. 45.18. What is the ratio of the Value added (current US$) in 1960 in South Africa to that in Thailand?
Your answer should be very brief. 0.78. What is the ratio of the Value added (current US$) of 1961 in South Africa to that in Thailand?
Keep it short and to the point. 0.78. What is the ratio of the Value added (current US$) of 1962 in South Africa to that in Thailand?
Your response must be concise. 0.77. What is the ratio of the Value added (current US$) of 1963 in South Africa to that in Thailand?
Give a very brief answer. 0.81. What is the ratio of the Value added (current US$) of 1960 in Sri Lanka to that in Sudan?
Provide a short and direct response. 0.82. What is the ratio of the Value added (current US$) of 1961 in Sri Lanka to that in Sudan?
Provide a short and direct response. 0.77. What is the ratio of the Value added (current US$) of 1962 in Sri Lanka to that in Sudan?
Your response must be concise. 0.7. What is the ratio of the Value added (current US$) of 1963 in Sri Lanka to that in Sudan?
Your answer should be very brief. 0.68. What is the ratio of the Value added (current US$) of 1960 in Sri Lanka to that in Swaziland?
Ensure brevity in your answer.  42.89. What is the ratio of the Value added (current US$) in 1961 in Sri Lanka to that in Swaziland?
Your response must be concise. 37.43. What is the ratio of the Value added (current US$) of 1962 in Sri Lanka to that in Swaziland?
Your answer should be very brief. 29.12. What is the ratio of the Value added (current US$) of 1963 in Sri Lanka to that in Swaziland?
Ensure brevity in your answer.  19.66. What is the ratio of the Value added (current US$) in 1960 in Sri Lanka to that in Thailand?
Keep it short and to the point. 0.47. What is the ratio of the Value added (current US$) of 1961 in Sri Lanka to that in Thailand?
Your answer should be very brief. 0.45. What is the ratio of the Value added (current US$) in 1962 in Sri Lanka to that in Thailand?
Offer a very short reply. 0.41. What is the ratio of the Value added (current US$) in 1963 in Sri Lanka to that in Thailand?
Your response must be concise. 0.35. What is the ratio of the Value added (current US$) in 1960 in Sudan to that in Swaziland?
Your answer should be compact. 52.37. What is the ratio of the Value added (current US$) of 1961 in Sudan to that in Swaziland?
Provide a short and direct response. 48.37. What is the ratio of the Value added (current US$) of 1962 in Sudan to that in Swaziland?
Keep it short and to the point. 41.51. What is the ratio of the Value added (current US$) in 1963 in Sudan to that in Swaziland?
Keep it short and to the point. 28.86. What is the ratio of the Value added (current US$) in 1960 in Sudan to that in Thailand?
Your response must be concise. 0.58. What is the ratio of the Value added (current US$) of 1961 in Sudan to that in Thailand?
Provide a short and direct response. 0.58. What is the ratio of the Value added (current US$) in 1962 in Sudan to that in Thailand?
Your answer should be compact. 0.59. What is the ratio of the Value added (current US$) of 1963 in Sudan to that in Thailand?
Keep it short and to the point. 0.52. What is the ratio of the Value added (current US$) in 1960 in Swaziland to that in Thailand?
Your answer should be compact. 0.01. What is the ratio of the Value added (current US$) in 1961 in Swaziland to that in Thailand?
Your response must be concise. 0.01. What is the ratio of the Value added (current US$) in 1962 in Swaziland to that in Thailand?
Provide a short and direct response. 0.01. What is the ratio of the Value added (current US$) in 1963 in Swaziland to that in Thailand?
Offer a very short reply. 0.02. What is the difference between the highest and the second highest Value added (current US$) of 1960?
Your answer should be very brief. 2.23e+08. What is the difference between the highest and the second highest Value added (current US$) in 1961?
Keep it short and to the point. 2.37e+08. What is the difference between the highest and the second highest Value added (current US$) of 1962?
Ensure brevity in your answer.  2.55e+08. What is the difference between the highest and the second highest Value added (current US$) in 1963?
Keep it short and to the point. 2.22e+08. What is the difference between the highest and the lowest Value added (current US$) in 1960?
Give a very brief answer. 9.95e+08. What is the difference between the highest and the lowest Value added (current US$) in 1961?
Make the answer very short. 1.07e+09. What is the difference between the highest and the lowest Value added (current US$) in 1962?
Your answer should be compact. 1.11e+09. What is the difference between the highest and the lowest Value added (current US$) of 1963?
Offer a very short reply. 1.15e+09. 